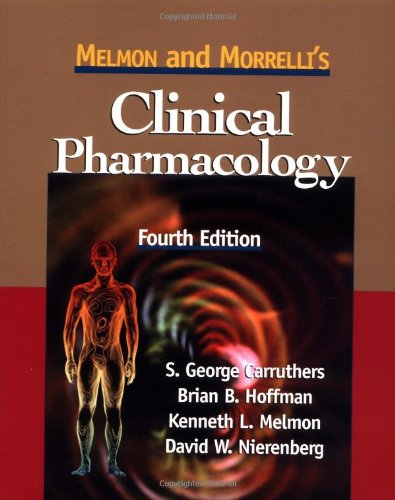Who wrote this book?
Answer the question using a single word or phrase. S. Carruthers What is the title of this book? Melmon and Morrelli's Clinical Pharmacology What is the genre of this book? Medical Books Is this a pharmaceutical book? Yes Is this a sociopolitical book? No 